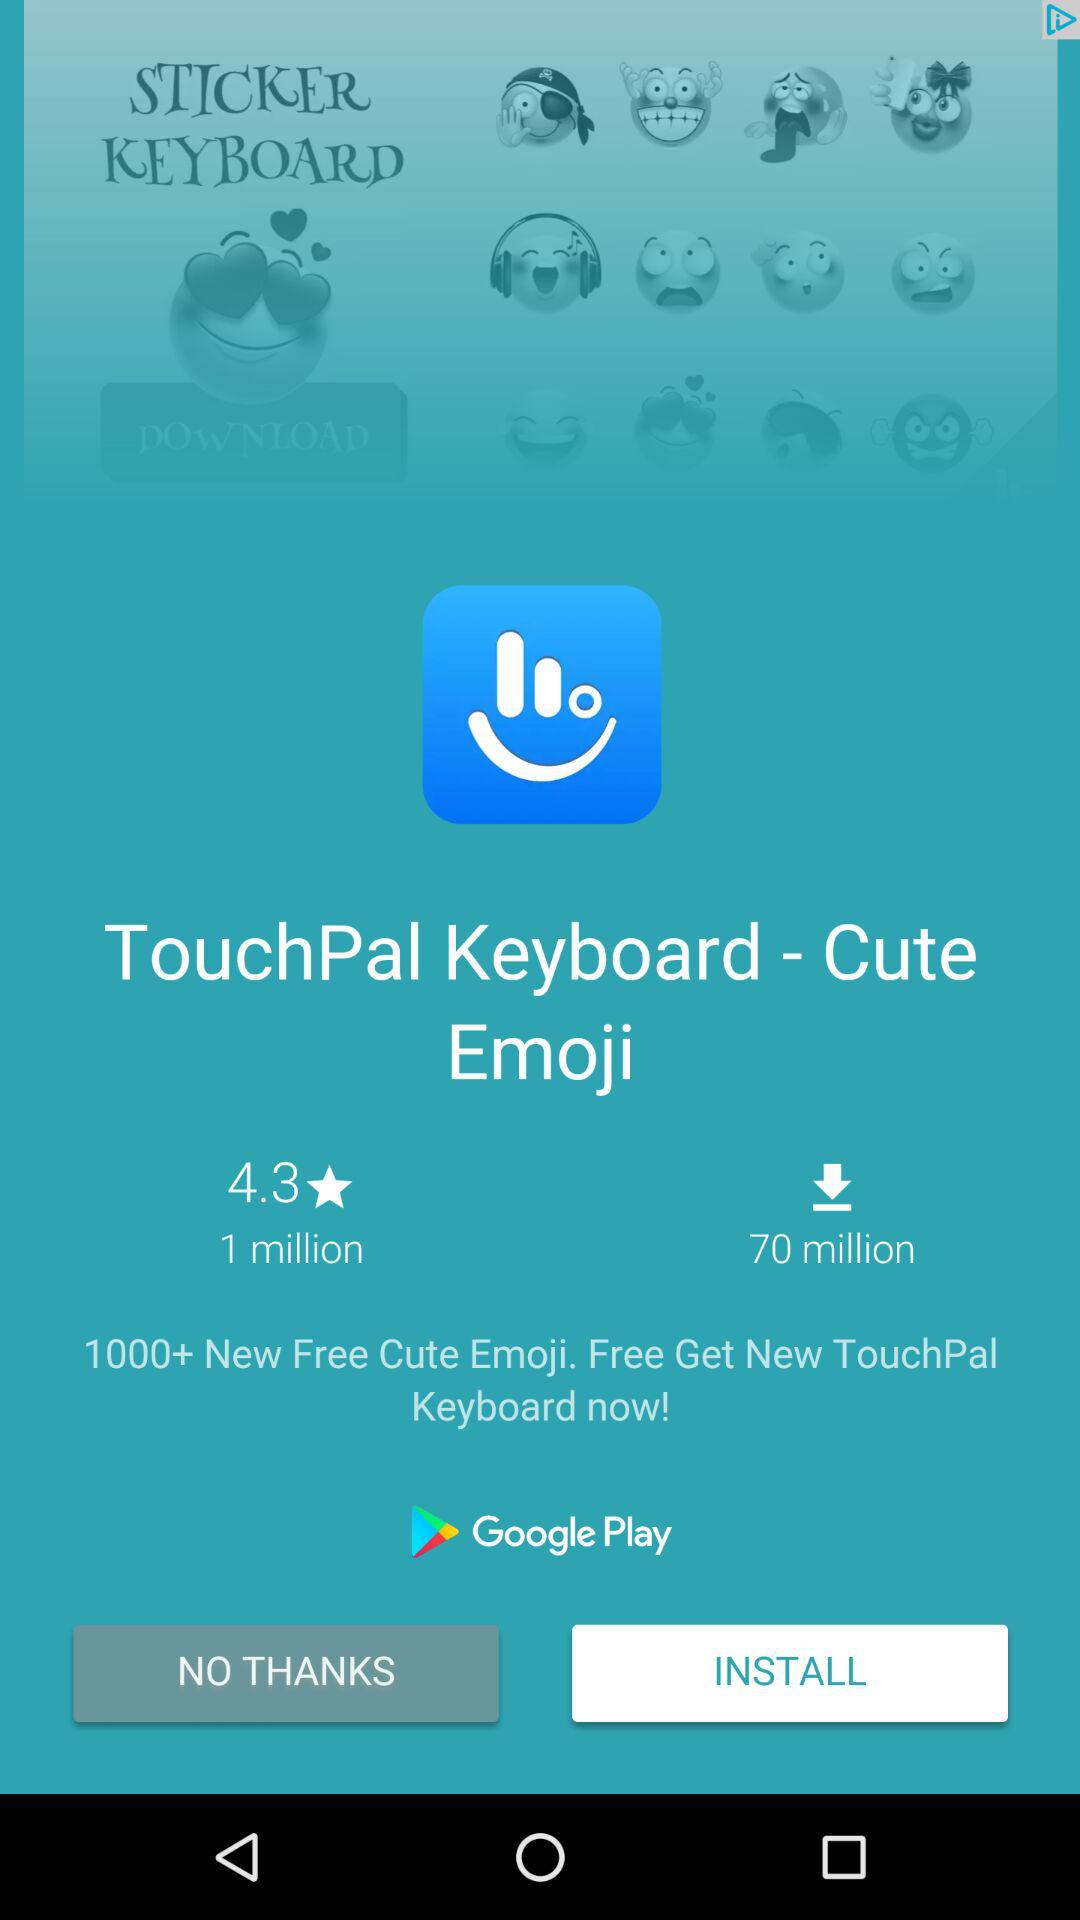What is the rating of the application? The rating of the application is 4.3. 